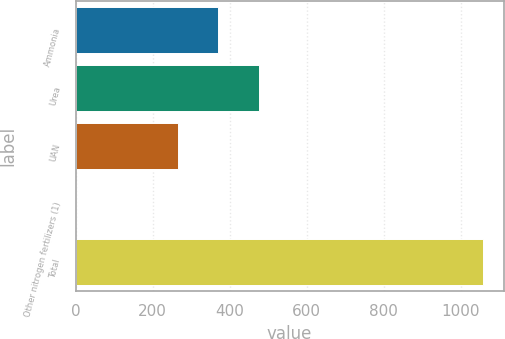Convert chart. <chart><loc_0><loc_0><loc_500><loc_500><bar_chart><fcel>Ammonia<fcel>Urea<fcel>UAN<fcel>Other nitrogen fertilizers (1)<fcel>Total<nl><fcel>370.78<fcel>476.36<fcel>265.2<fcel>2.4<fcel>1058.2<nl></chart> 